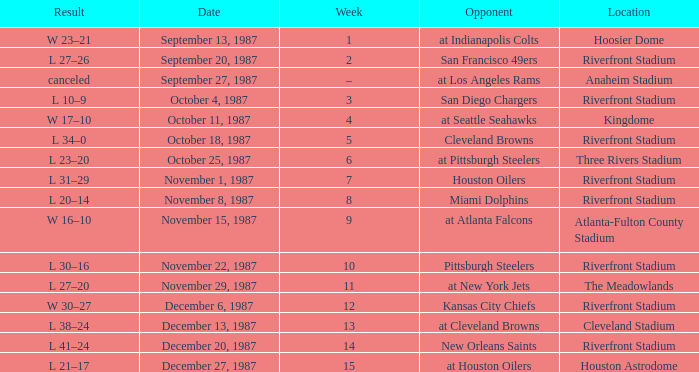What was the result of the game at the Riverfront Stadium after week 8? L 20–14. 